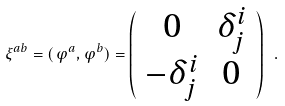Convert formula to latex. <formula><loc_0><loc_0><loc_500><loc_500>\xi ^ { a b } = ( \varphi ^ { a } , \varphi ^ { b } ) = \left ( \begin{array} { c c } 0 & \delta ^ { i } _ { j } \\ - \delta ^ { i } _ { j } & 0 \end{array} \right ) \ .</formula> 